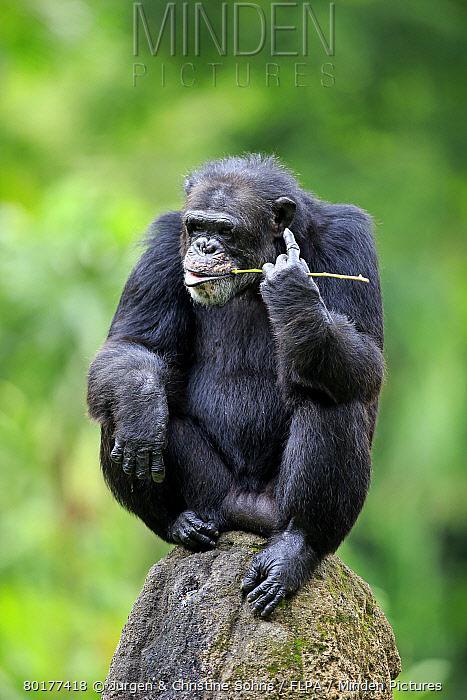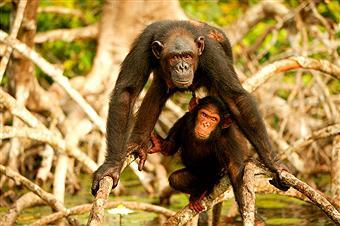The first image is the image on the left, the second image is the image on the right. Considering the images on both sides, is "An image shows exactly one chimp, in a squatting position with forearms on knees." valid? Answer yes or no. Yes. 